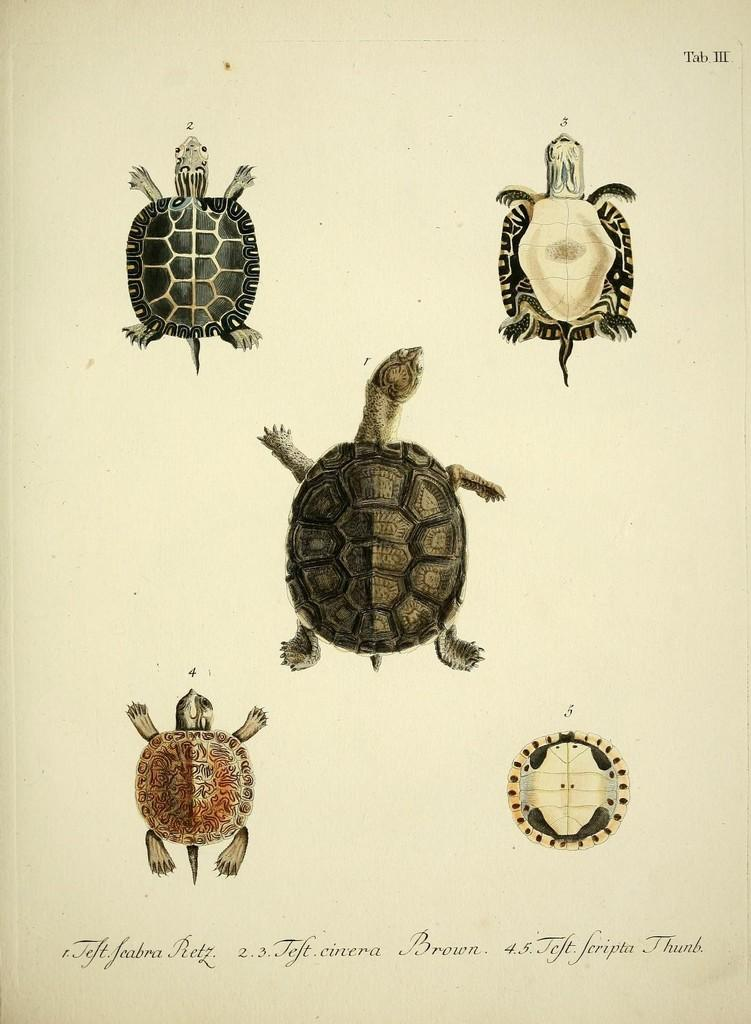What medium was used to create the art in the image? The image is an art piece done on paper. How were the different colors achieved in the art? Different color pencils were used to create the art. What can be found at the bottom of the image? There is text at the bottom of the image. What type of animals are depicted in the art? There are images of turtles and a tortoise in the art. How many cobwebs are present in the image? There are no cobwebs present in the image; it is an art piece featuring turtles and a tortoise. 